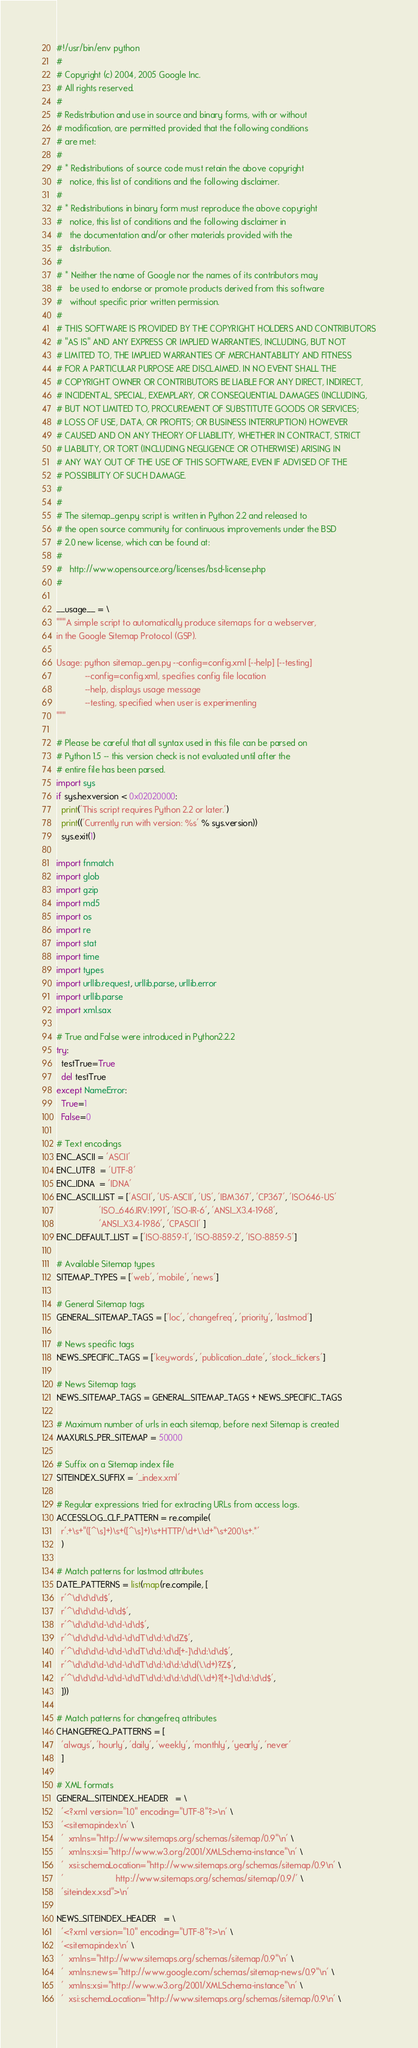<code> <loc_0><loc_0><loc_500><loc_500><_Python_>#!/usr/bin/env python
#
# Copyright (c) 2004, 2005 Google Inc.
# All rights reserved.
#
# Redistribution and use in source and binary forms, with or without
# modification, are permitted provided that the following conditions
# are met:
#
# * Redistributions of source code must retain the above copyright
#   notice, this list of conditions and the following disclaimer.
#
# * Redistributions in binary form must reproduce the above copyright
#   notice, this list of conditions and the following disclaimer in
#   the documentation and/or other materials provided with the
#   distribution.
#
# * Neither the name of Google nor the names of its contributors may
#   be used to endorse or promote products derived from this software
#   without specific prior written permission.
#
# THIS SOFTWARE IS PROVIDED BY THE COPYRIGHT HOLDERS AND CONTRIBUTORS
# "AS IS" AND ANY EXPRESS OR IMPLIED WARRANTIES, INCLUDING, BUT NOT
# LIMITED TO, THE IMPLIED WARRANTIES OF MERCHANTABILITY AND FITNESS
# FOR A PARTICULAR PURPOSE ARE DISCLAIMED. IN NO EVENT SHALL THE
# COPYRIGHT OWNER OR CONTRIBUTORS BE LIABLE FOR ANY DIRECT, INDIRECT,
# INCIDENTAL, SPECIAL, EXEMPLARY, OR CONSEQUENTIAL DAMAGES (INCLUDING,
# BUT NOT LIMITED TO, PROCUREMENT OF SUBSTITUTE GOODS OR SERVICES;
# LOSS OF USE, DATA, OR PROFITS; OR BUSINESS INTERRUPTION) HOWEVER
# CAUSED AND ON ANY THEORY OF LIABILITY, WHETHER IN CONTRACT, STRICT
# LIABILITY, OR TORT (INCLUDING NEGLIGENCE OR OTHERWISE) ARISING IN
# ANY WAY OUT OF THE USE OF THIS SOFTWARE, EVEN IF ADVISED OF THE
# POSSIBILITY OF SUCH DAMAGE.
#
#
# The sitemap_gen.py script is written in Python 2.2 and released to
# the open source community for continuous improvements under the BSD
# 2.0 new license, which can be found at:
#
#   http://www.opensource.org/licenses/bsd-license.php
#

__usage__ = \
"""A simple script to automatically produce sitemaps for a webserver,
in the Google Sitemap Protocol (GSP).

Usage: python sitemap_gen.py --config=config.xml [--help] [--testing]
            --config=config.xml, specifies config file location
            --help, displays usage message
            --testing, specified when user is experimenting
"""

# Please be careful that all syntax used in this file can be parsed on
# Python 1.5 -- this version check is not evaluated until after the
# entire file has been parsed.
import sys
if sys.hexversion < 0x02020000:
  print('This script requires Python 2.2 or later.')
  print(('Currently run with version: %s' % sys.version))
  sys.exit(1)

import fnmatch
import glob
import gzip
import md5
import os
import re
import stat
import time
import types
import urllib.request, urllib.parse, urllib.error
import urllib.parse
import xml.sax

# True and False were introduced in Python2.2.2
try:
  testTrue=True
  del testTrue
except NameError:
  True=1
  False=0

# Text encodings
ENC_ASCII = 'ASCII'
ENC_UTF8  = 'UTF-8'
ENC_IDNA  = 'IDNA'
ENC_ASCII_LIST = ['ASCII', 'US-ASCII', 'US', 'IBM367', 'CP367', 'ISO646-US'
                  'ISO_646.IRV:1991', 'ISO-IR-6', 'ANSI_X3.4-1968',
                  'ANSI_X3.4-1986', 'CPASCII' ]
ENC_DEFAULT_LIST = ['ISO-8859-1', 'ISO-8859-2', 'ISO-8859-5']

# Available Sitemap types
SITEMAP_TYPES = ['web', 'mobile', 'news']

# General Sitemap tags
GENERAL_SITEMAP_TAGS = ['loc', 'changefreq', 'priority', 'lastmod']

# News specific tags
NEWS_SPECIFIC_TAGS = ['keywords', 'publication_date', 'stock_tickers']

# News Sitemap tags
NEWS_SITEMAP_TAGS = GENERAL_SITEMAP_TAGS + NEWS_SPECIFIC_TAGS

# Maximum number of urls in each sitemap, before next Sitemap is created
MAXURLS_PER_SITEMAP = 50000

# Suffix on a Sitemap index file
SITEINDEX_SUFFIX = '_index.xml'

# Regular expressions tried for extracting URLs from access logs.
ACCESSLOG_CLF_PATTERN = re.compile(
  r'.+\s+"([^\s]+)\s+([^\s]+)\s+HTTP/\d+\.\d+"\s+200\s+.*'
  )

# Match patterns for lastmod attributes
DATE_PATTERNS = list(map(re.compile, [
  r'^\d\d\d\d$',
  r'^\d\d\d\d-\d\d$',
  r'^\d\d\d\d-\d\d-\d\d$',
  r'^\d\d\d\d-\d\d-\d\dT\d\d:\d\dZ$',
  r'^\d\d\d\d-\d\d-\d\dT\d\d:\d\d[+-]\d\d:\d\d$',
  r'^\d\d\d\d-\d\d-\d\dT\d\d:\d\d:\d\d(\.\d+)?Z$',
  r'^\d\d\d\d-\d\d-\d\dT\d\d:\d\d:\d\d(\.\d+)?[+-]\d\d:\d\d$',
  ]))

# Match patterns for changefreq attributes
CHANGEFREQ_PATTERNS = [
  'always', 'hourly', 'daily', 'weekly', 'monthly', 'yearly', 'never'
  ]

# XML formats
GENERAL_SITEINDEX_HEADER   = \
  '<?xml version="1.0" encoding="UTF-8"?>\n' \
  '<sitemapindex\n' \
  '  xmlns="http://www.sitemaps.org/schemas/sitemap/0.9"\n' \
  '  xmlns:xsi="http://www.w3.org/2001/XMLSchema-instance"\n' \
  '  xsi:schemaLocation="http://www.sitemaps.org/schemas/sitemap/0.9\n' \
  '                      http://www.sitemaps.org/schemas/sitemap/0.9/' \
  'siteindex.xsd">\n'

NEWS_SITEINDEX_HEADER   = \
  '<?xml version="1.0" encoding="UTF-8"?>\n' \
  '<sitemapindex\n' \
  '  xmlns="http://www.sitemaps.org/schemas/sitemap/0.9"\n' \
  '  xmlns:news="http://www.google.com/schemas/sitemap-news/0.9"\n' \
  '  xmlns:xsi="http://www.w3.org/2001/XMLSchema-instance"\n' \
  '  xsi:schemaLocation="http://www.sitemaps.org/schemas/sitemap/0.9\n' \</code> 